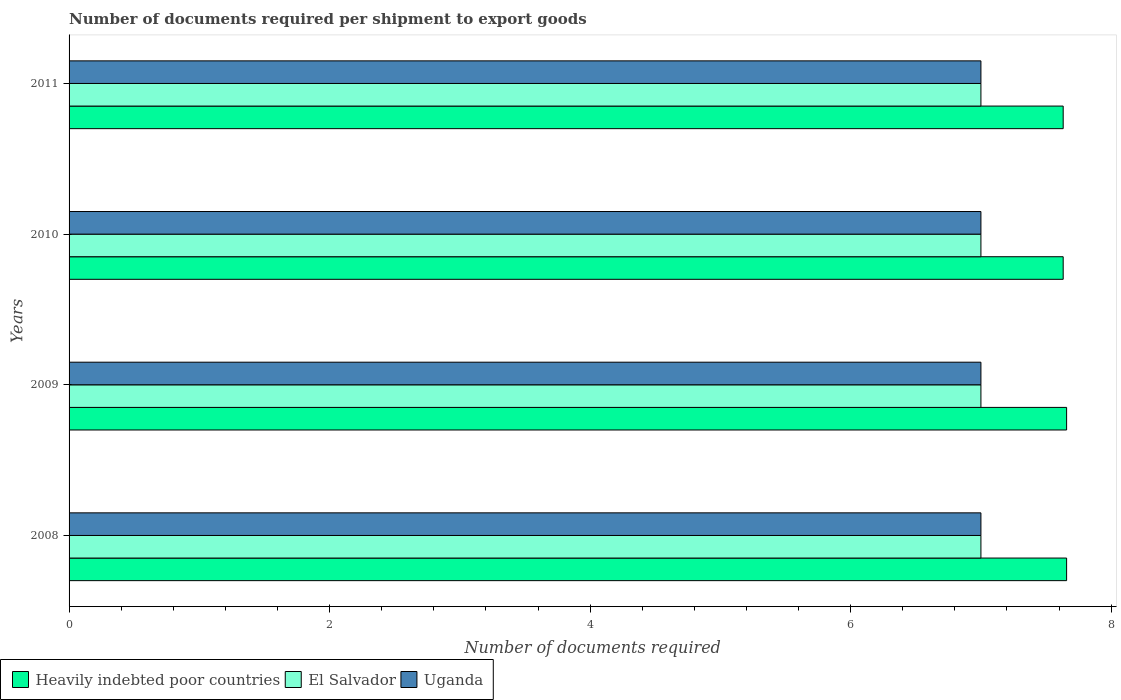Are the number of bars per tick equal to the number of legend labels?
Keep it short and to the point. Yes. Are the number of bars on each tick of the Y-axis equal?
Make the answer very short. Yes. How many bars are there on the 3rd tick from the bottom?
Give a very brief answer. 3. What is the label of the 4th group of bars from the top?
Provide a short and direct response. 2008. What is the number of documents required per shipment to export goods in El Salvador in 2011?
Offer a terse response. 7. Across all years, what is the maximum number of documents required per shipment to export goods in Uganda?
Ensure brevity in your answer.  7. Across all years, what is the minimum number of documents required per shipment to export goods in Heavily indebted poor countries?
Provide a short and direct response. 7.63. In which year was the number of documents required per shipment to export goods in El Salvador minimum?
Make the answer very short. 2008. What is the total number of documents required per shipment to export goods in Heavily indebted poor countries in the graph?
Your answer should be compact. 30.58. What is the difference between the number of documents required per shipment to export goods in Heavily indebted poor countries in 2008 and that in 2011?
Provide a short and direct response. 0.03. What is the difference between the number of documents required per shipment to export goods in Heavily indebted poor countries in 2009 and the number of documents required per shipment to export goods in El Salvador in 2008?
Your answer should be very brief. 0.66. What is the average number of documents required per shipment to export goods in Uganda per year?
Provide a succinct answer. 7. In the year 2009, what is the difference between the number of documents required per shipment to export goods in Uganda and number of documents required per shipment to export goods in Heavily indebted poor countries?
Your response must be concise. -0.66. In how many years, is the number of documents required per shipment to export goods in El Salvador greater than 7.6 ?
Keep it short and to the point. 0. What is the ratio of the number of documents required per shipment to export goods in Heavily indebted poor countries in 2010 to that in 2011?
Your answer should be compact. 1. Is the difference between the number of documents required per shipment to export goods in Uganda in 2010 and 2011 greater than the difference between the number of documents required per shipment to export goods in Heavily indebted poor countries in 2010 and 2011?
Your answer should be compact. No. In how many years, is the number of documents required per shipment to export goods in Uganda greater than the average number of documents required per shipment to export goods in Uganda taken over all years?
Your answer should be very brief. 0. What does the 2nd bar from the top in 2011 represents?
Ensure brevity in your answer.  El Salvador. What does the 3rd bar from the bottom in 2009 represents?
Make the answer very short. Uganda. How many bars are there?
Offer a terse response. 12. Are all the bars in the graph horizontal?
Make the answer very short. Yes. What is the difference between two consecutive major ticks on the X-axis?
Provide a succinct answer. 2. Does the graph contain any zero values?
Keep it short and to the point. No. Does the graph contain grids?
Your response must be concise. No. How many legend labels are there?
Provide a short and direct response. 3. What is the title of the graph?
Your response must be concise. Number of documents required per shipment to export goods. Does "Lower middle income" appear as one of the legend labels in the graph?
Offer a very short reply. No. What is the label or title of the X-axis?
Provide a succinct answer. Number of documents required. What is the Number of documents required in Heavily indebted poor countries in 2008?
Offer a terse response. 7.66. What is the Number of documents required in El Salvador in 2008?
Provide a succinct answer. 7. What is the Number of documents required of Uganda in 2008?
Ensure brevity in your answer.  7. What is the Number of documents required of Heavily indebted poor countries in 2009?
Your answer should be very brief. 7.66. What is the Number of documents required of El Salvador in 2009?
Give a very brief answer. 7. What is the Number of documents required of Uganda in 2009?
Give a very brief answer. 7. What is the Number of documents required in Heavily indebted poor countries in 2010?
Your answer should be compact. 7.63. What is the Number of documents required in El Salvador in 2010?
Provide a succinct answer. 7. What is the Number of documents required in Uganda in 2010?
Give a very brief answer. 7. What is the Number of documents required in Heavily indebted poor countries in 2011?
Give a very brief answer. 7.63. What is the Number of documents required of El Salvador in 2011?
Your answer should be very brief. 7. Across all years, what is the maximum Number of documents required in Heavily indebted poor countries?
Provide a succinct answer. 7.66. Across all years, what is the maximum Number of documents required in Uganda?
Your answer should be very brief. 7. Across all years, what is the minimum Number of documents required in Heavily indebted poor countries?
Offer a terse response. 7.63. Across all years, what is the minimum Number of documents required of Uganda?
Offer a terse response. 7. What is the total Number of documents required of Heavily indebted poor countries in the graph?
Give a very brief answer. 30.58. What is the total Number of documents required in El Salvador in the graph?
Your answer should be very brief. 28. What is the difference between the Number of documents required of Heavily indebted poor countries in 2008 and that in 2010?
Offer a terse response. 0.03. What is the difference between the Number of documents required of Heavily indebted poor countries in 2008 and that in 2011?
Your answer should be compact. 0.03. What is the difference between the Number of documents required of Uganda in 2008 and that in 2011?
Your response must be concise. 0. What is the difference between the Number of documents required in Heavily indebted poor countries in 2009 and that in 2010?
Ensure brevity in your answer.  0.03. What is the difference between the Number of documents required in Uganda in 2009 and that in 2010?
Provide a short and direct response. 0. What is the difference between the Number of documents required in Heavily indebted poor countries in 2009 and that in 2011?
Your answer should be very brief. 0.03. What is the difference between the Number of documents required of Uganda in 2009 and that in 2011?
Provide a succinct answer. 0. What is the difference between the Number of documents required in El Salvador in 2010 and that in 2011?
Your response must be concise. 0. What is the difference between the Number of documents required of Uganda in 2010 and that in 2011?
Ensure brevity in your answer.  0. What is the difference between the Number of documents required of Heavily indebted poor countries in 2008 and the Number of documents required of El Salvador in 2009?
Provide a succinct answer. 0.66. What is the difference between the Number of documents required of Heavily indebted poor countries in 2008 and the Number of documents required of Uganda in 2009?
Offer a terse response. 0.66. What is the difference between the Number of documents required in Heavily indebted poor countries in 2008 and the Number of documents required in El Salvador in 2010?
Your answer should be compact. 0.66. What is the difference between the Number of documents required in Heavily indebted poor countries in 2008 and the Number of documents required in Uganda in 2010?
Provide a short and direct response. 0.66. What is the difference between the Number of documents required in El Salvador in 2008 and the Number of documents required in Uganda in 2010?
Your response must be concise. 0. What is the difference between the Number of documents required of Heavily indebted poor countries in 2008 and the Number of documents required of El Salvador in 2011?
Offer a terse response. 0.66. What is the difference between the Number of documents required of Heavily indebted poor countries in 2008 and the Number of documents required of Uganda in 2011?
Provide a short and direct response. 0.66. What is the difference between the Number of documents required of Heavily indebted poor countries in 2009 and the Number of documents required of El Salvador in 2010?
Keep it short and to the point. 0.66. What is the difference between the Number of documents required in Heavily indebted poor countries in 2009 and the Number of documents required in Uganda in 2010?
Offer a very short reply. 0.66. What is the difference between the Number of documents required of Heavily indebted poor countries in 2009 and the Number of documents required of El Salvador in 2011?
Your answer should be compact. 0.66. What is the difference between the Number of documents required of Heavily indebted poor countries in 2009 and the Number of documents required of Uganda in 2011?
Offer a terse response. 0.66. What is the difference between the Number of documents required of Heavily indebted poor countries in 2010 and the Number of documents required of El Salvador in 2011?
Make the answer very short. 0.63. What is the difference between the Number of documents required in Heavily indebted poor countries in 2010 and the Number of documents required in Uganda in 2011?
Ensure brevity in your answer.  0.63. What is the average Number of documents required in Heavily indebted poor countries per year?
Ensure brevity in your answer.  7.64. What is the average Number of documents required of El Salvador per year?
Give a very brief answer. 7. In the year 2008, what is the difference between the Number of documents required of Heavily indebted poor countries and Number of documents required of El Salvador?
Provide a succinct answer. 0.66. In the year 2008, what is the difference between the Number of documents required of Heavily indebted poor countries and Number of documents required of Uganda?
Keep it short and to the point. 0.66. In the year 2009, what is the difference between the Number of documents required of Heavily indebted poor countries and Number of documents required of El Salvador?
Provide a succinct answer. 0.66. In the year 2009, what is the difference between the Number of documents required in Heavily indebted poor countries and Number of documents required in Uganda?
Provide a short and direct response. 0.66. In the year 2009, what is the difference between the Number of documents required in El Salvador and Number of documents required in Uganda?
Make the answer very short. 0. In the year 2010, what is the difference between the Number of documents required in Heavily indebted poor countries and Number of documents required in El Salvador?
Provide a succinct answer. 0.63. In the year 2010, what is the difference between the Number of documents required of Heavily indebted poor countries and Number of documents required of Uganda?
Make the answer very short. 0.63. In the year 2010, what is the difference between the Number of documents required in El Salvador and Number of documents required in Uganda?
Provide a short and direct response. 0. In the year 2011, what is the difference between the Number of documents required of Heavily indebted poor countries and Number of documents required of El Salvador?
Keep it short and to the point. 0.63. In the year 2011, what is the difference between the Number of documents required of Heavily indebted poor countries and Number of documents required of Uganda?
Keep it short and to the point. 0.63. What is the ratio of the Number of documents required in Heavily indebted poor countries in 2008 to that in 2009?
Give a very brief answer. 1. What is the ratio of the Number of documents required of Heavily indebted poor countries in 2008 to that in 2010?
Offer a very short reply. 1. What is the ratio of the Number of documents required of Uganda in 2008 to that in 2010?
Your answer should be very brief. 1. What is the ratio of the Number of documents required in Heavily indebted poor countries in 2008 to that in 2011?
Offer a terse response. 1. What is the ratio of the Number of documents required in El Salvador in 2008 to that in 2011?
Your response must be concise. 1. What is the ratio of the Number of documents required in Heavily indebted poor countries in 2009 to that in 2010?
Provide a short and direct response. 1. What is the ratio of the Number of documents required of El Salvador in 2009 to that in 2010?
Offer a very short reply. 1. What is the ratio of the Number of documents required in Uganda in 2009 to that in 2010?
Keep it short and to the point. 1. What is the ratio of the Number of documents required of Heavily indebted poor countries in 2010 to that in 2011?
Your response must be concise. 1. What is the difference between the highest and the second highest Number of documents required in Heavily indebted poor countries?
Make the answer very short. 0. What is the difference between the highest and the second highest Number of documents required of Uganda?
Provide a succinct answer. 0. What is the difference between the highest and the lowest Number of documents required of Heavily indebted poor countries?
Your response must be concise. 0.03. 